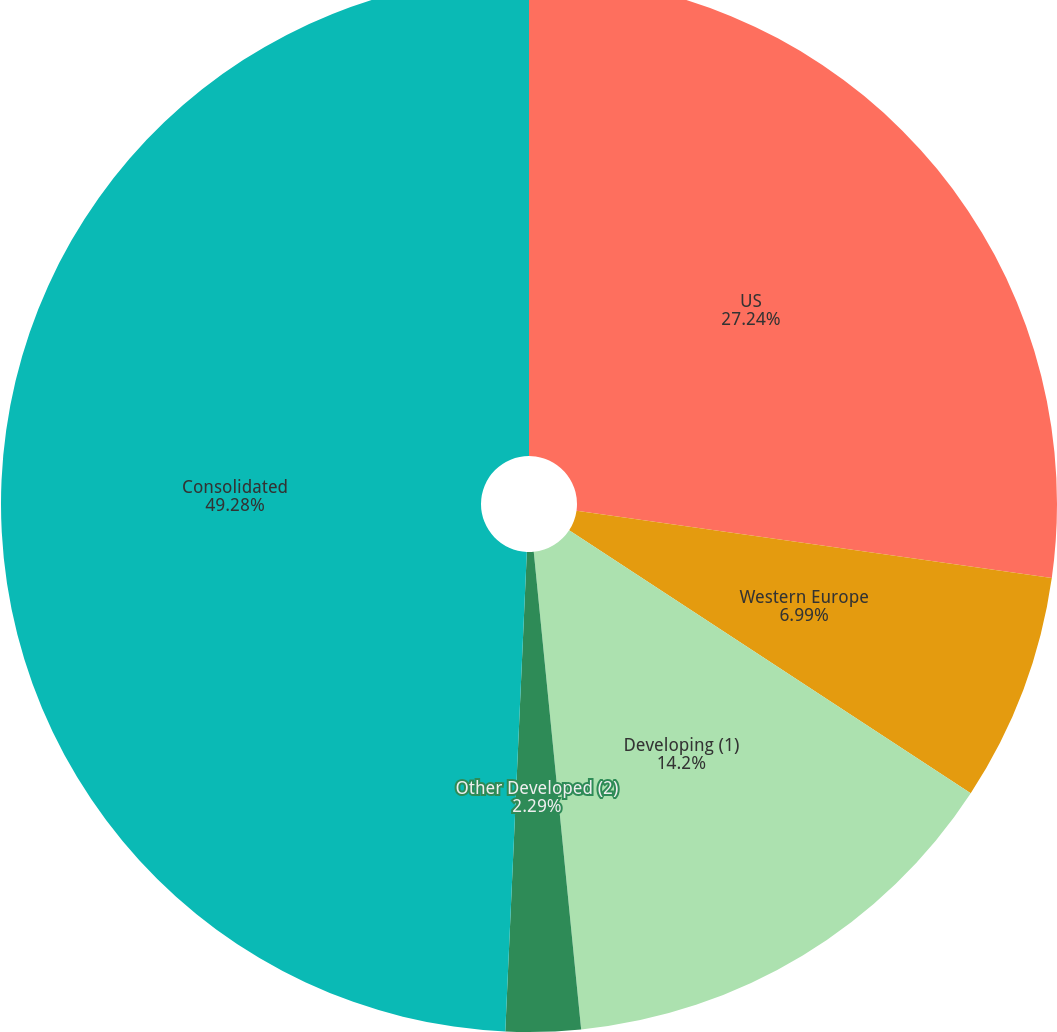Convert chart. <chart><loc_0><loc_0><loc_500><loc_500><pie_chart><fcel>US<fcel>Western Europe<fcel>Developing (1)<fcel>Other Developed (2)<fcel>Consolidated<nl><fcel>27.24%<fcel>6.99%<fcel>14.2%<fcel>2.29%<fcel>49.29%<nl></chart> 